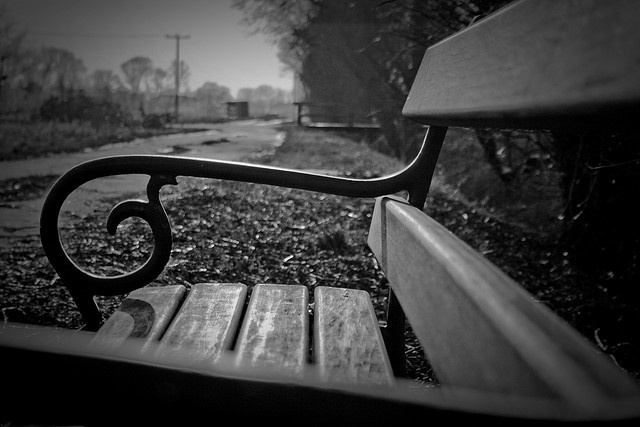Describe the objects in this image and their specific colors. I can see a bench in black, gray, darkgray, and lightgray tones in this image. 